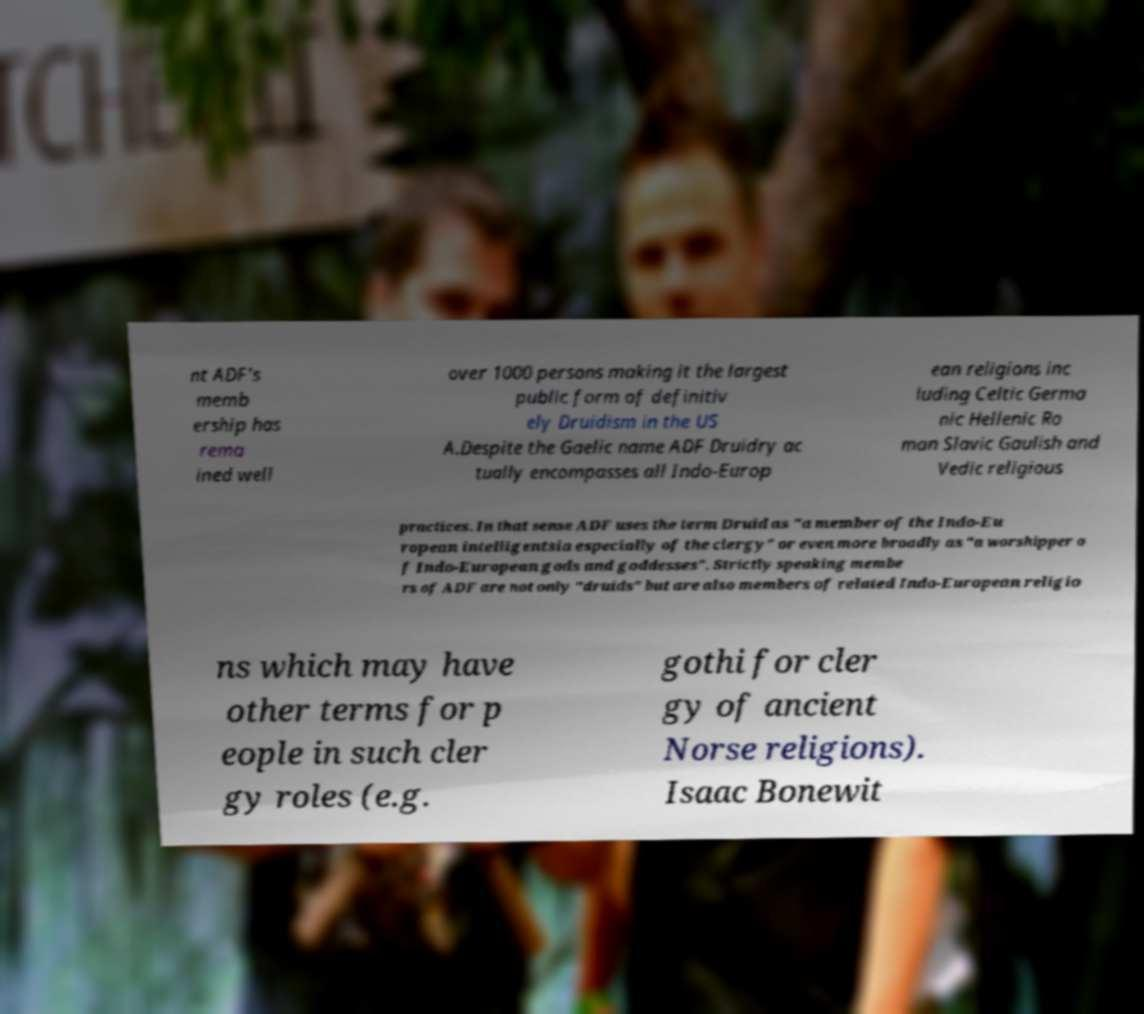What messages or text are displayed in this image? I need them in a readable, typed format. nt ADF's memb ership has rema ined well over 1000 persons making it the largest public form of definitiv ely Druidism in the US A.Despite the Gaelic name ADF Druidry ac tually encompasses all Indo-Europ ean religions inc luding Celtic Germa nic Hellenic Ro man Slavic Gaulish and Vedic religious practices. In that sense ADF uses the term Druid as "a member of the Indo-Eu ropean intelligentsia especially of the clergy" or even more broadly as "a worshipper o f Indo-European gods and goddesses". Strictly speaking membe rs of ADF are not only "druids" but are also members of related Indo-European religio ns which may have other terms for p eople in such cler gy roles (e.g. gothi for cler gy of ancient Norse religions). Isaac Bonewit 